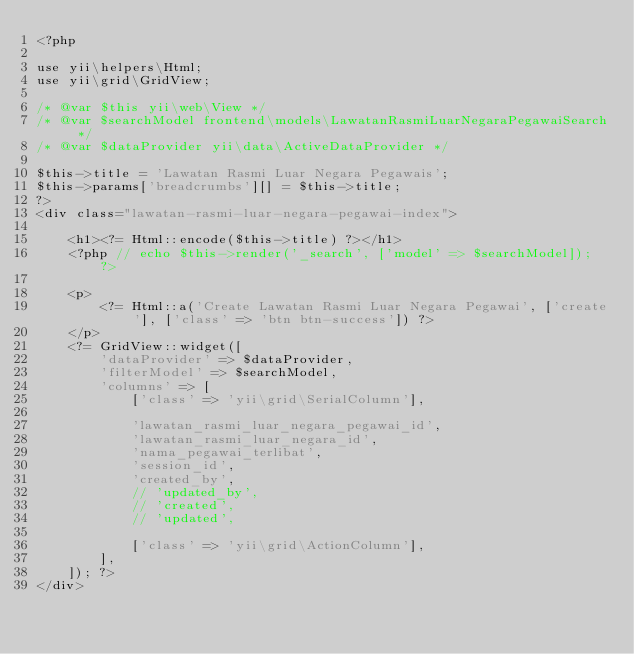Convert code to text. <code><loc_0><loc_0><loc_500><loc_500><_PHP_><?php

use yii\helpers\Html;
use yii\grid\GridView;

/* @var $this yii\web\View */
/* @var $searchModel frontend\models\LawatanRasmiLuarNegaraPegawaiSearch */
/* @var $dataProvider yii\data\ActiveDataProvider */

$this->title = 'Lawatan Rasmi Luar Negara Pegawais';
$this->params['breadcrumbs'][] = $this->title;
?>
<div class="lawatan-rasmi-luar-negara-pegawai-index">

    <h1><?= Html::encode($this->title) ?></h1>
    <?php // echo $this->render('_search', ['model' => $searchModel]); ?>

    <p>
        <?= Html::a('Create Lawatan Rasmi Luar Negara Pegawai', ['create'], ['class' => 'btn btn-success']) ?>
    </p>
    <?= GridView::widget([
        'dataProvider' => $dataProvider,
        'filterModel' => $searchModel,
        'columns' => [
            ['class' => 'yii\grid\SerialColumn'],

            'lawatan_rasmi_luar_negara_pegawai_id',
            'lawatan_rasmi_luar_negara_id',
            'nama_pegawai_terlibat',
            'session_id',
            'created_by',
            // 'updated_by',
            // 'created',
            // 'updated',

            ['class' => 'yii\grid\ActionColumn'],
        ],
    ]); ?>
</div>
</code> 